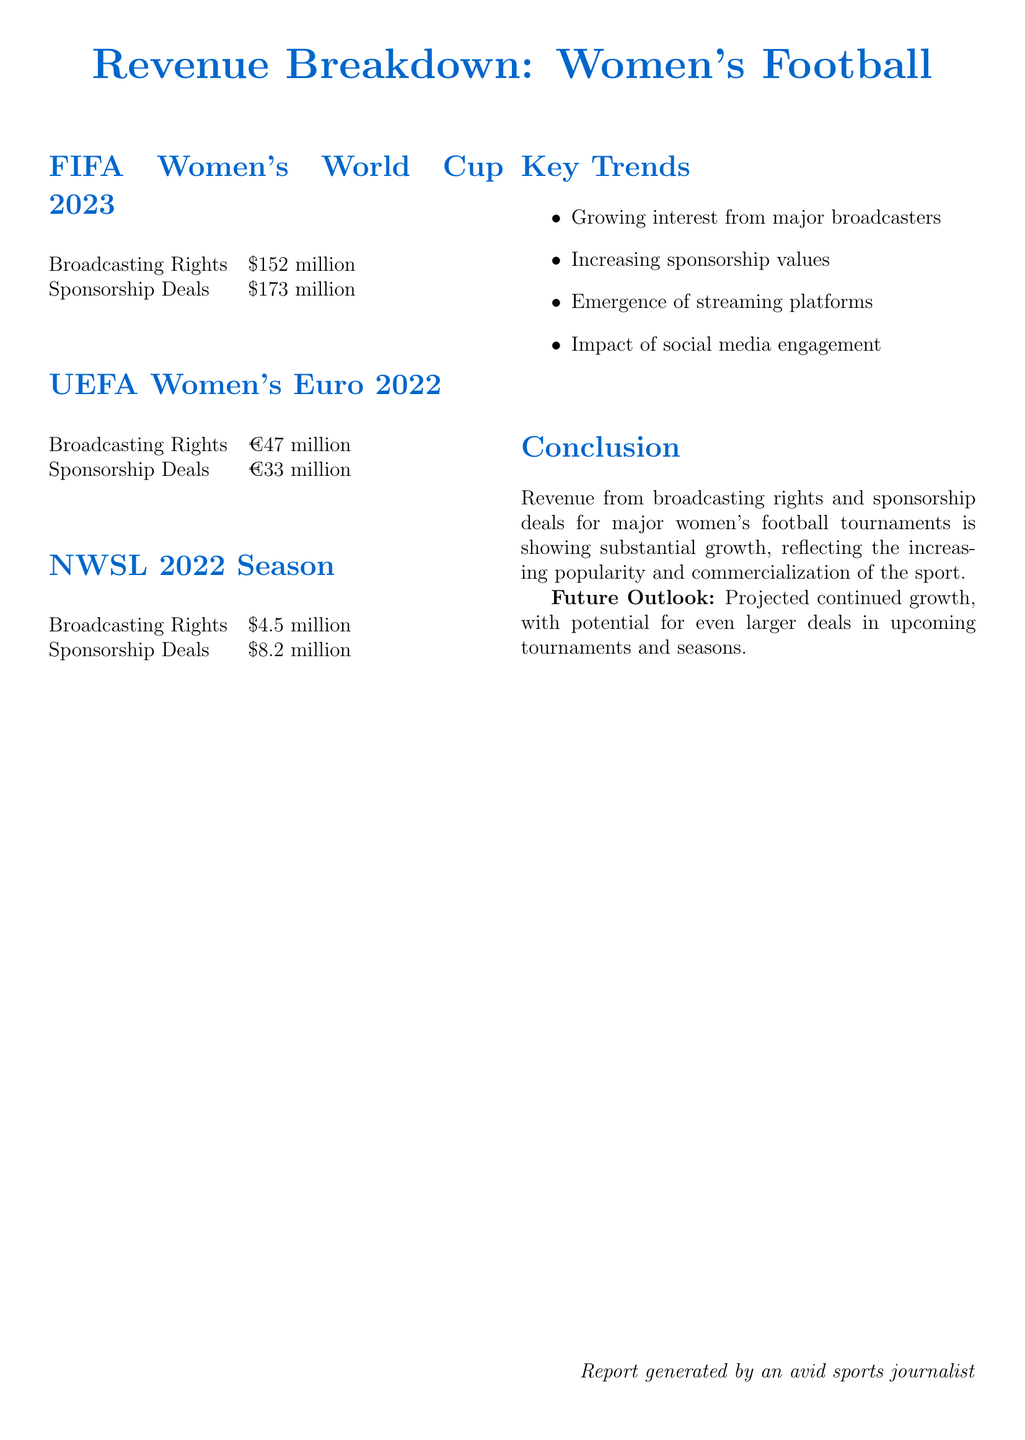What is the broadcasting rights revenue for FIFA Women's World Cup 2023? The document states that broadcasting rights revenue for FIFA Women's World Cup 2023 is $152 million.
Answer: $152 million What are the major sponsors of FIFA Women's World Cup 2023? The report lists Visa, Adidas, and Coca-Cola as major sponsors for FIFA Women's World Cup 2023.
Answer: Visa, Adidas, Coca-Cola How much revenue was generated from sponsorship deals in the UEFA Women's Euro 2022? The sponsorship deals revenue for UEFA Women's Euro 2022 is cited as €33 million in the document.
Answer: €33 million What was the broadcasting rights revenue for the NWSL 2022 season? The NWSL 2022 season's broadcasting rights revenue amounts to $4.5 million, according to the document.
Answer: $4.5 million What trend is noted about the emergence of broadcasting platforms? The document highlights the emergence of streaming platforms as significant players in broadcasting rights.
Answer: Streaming platforms What projected trend is mentioned for future revenues in women's football? The report mentions projected continued growth for future revenues in women's football tournaments and seasons.
Answer: Continued growth How much was the total revenue from broadcasting rights for UEFA Women's Euro 2022? The broadcasting rights revenue for UEFA Women's Euro 2022 is recorded as €47 million in the document.
Answer: €47 million What is the estimated sponsorship revenue for the NWSL 2022 season? The document states that the sponsorship revenue for the NWSL 2022 season is $8.2 million.
Answer: $8.2 million What notable conclusion is drawn about the growth of revenues in women's football? The conclusion notes that there is substantial growth in revenues from broadcasting rights and sponsorship deals reflecting popularity.
Answer: Substantial growth 